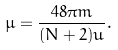<formula> <loc_0><loc_0><loc_500><loc_500>\mu = \frac { 4 8 \pi m } { ( N + 2 ) u } .</formula> 